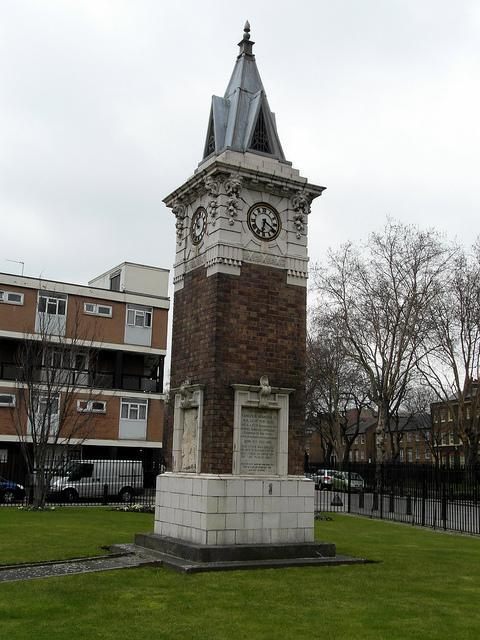What color are the square bricks outlining the base of this small clock tower? Please explain your reasoning. white. The other bricks are red. the square bricks at the base do not match the other bricks and are not black or tan. 